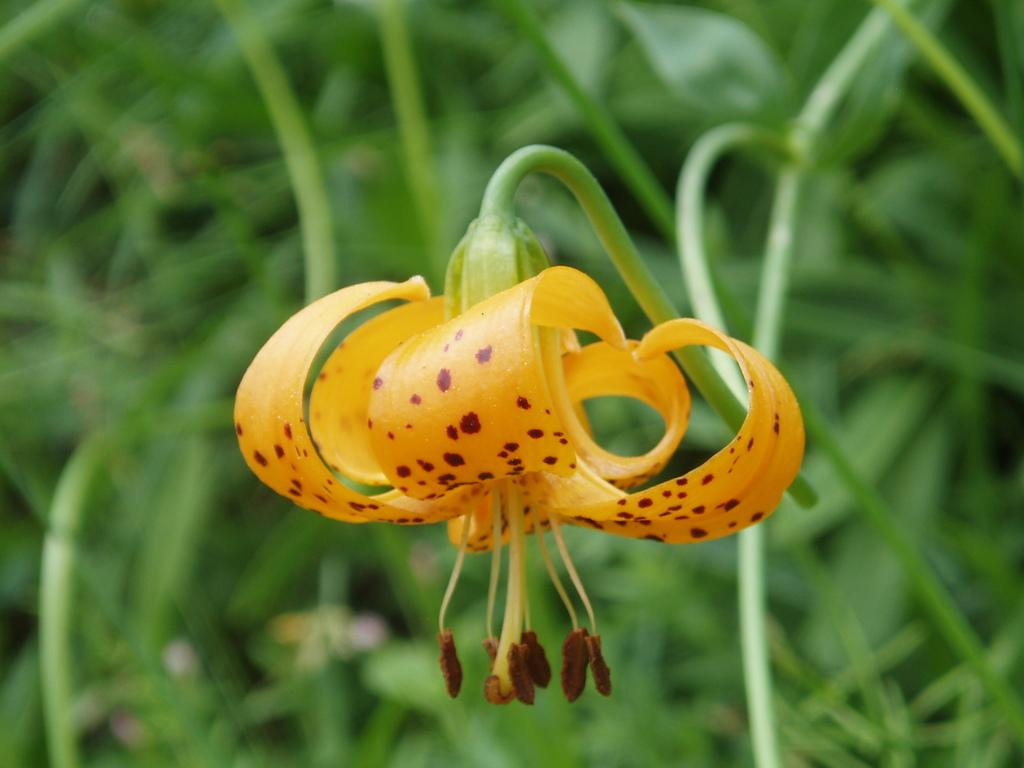What is the main subject of the image? There is a flower in the image. Can you describe the color of the flower? The flower is yellow. What else can be seen in the background of the image? There are leaves in the background of the image. What type of advertisement can be seen in the background of the image? There is no advertisement present in the image; it features a yellow flower and leaves in the background. What type of work is being done with the flower in the image? There is no indication of any work being done with the flower in the image; it is simply a flower and leaves in the background. 